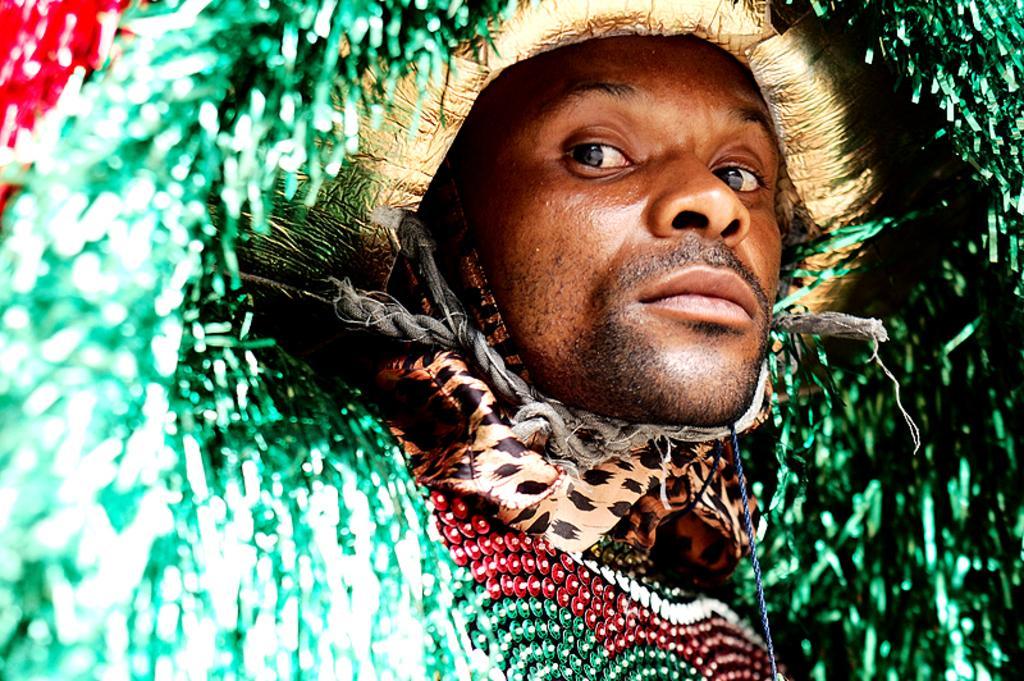In one or two sentences, can you explain what this image depicts? In this image, I can see the man. He wore a fancy dress, which is green and red in color. 